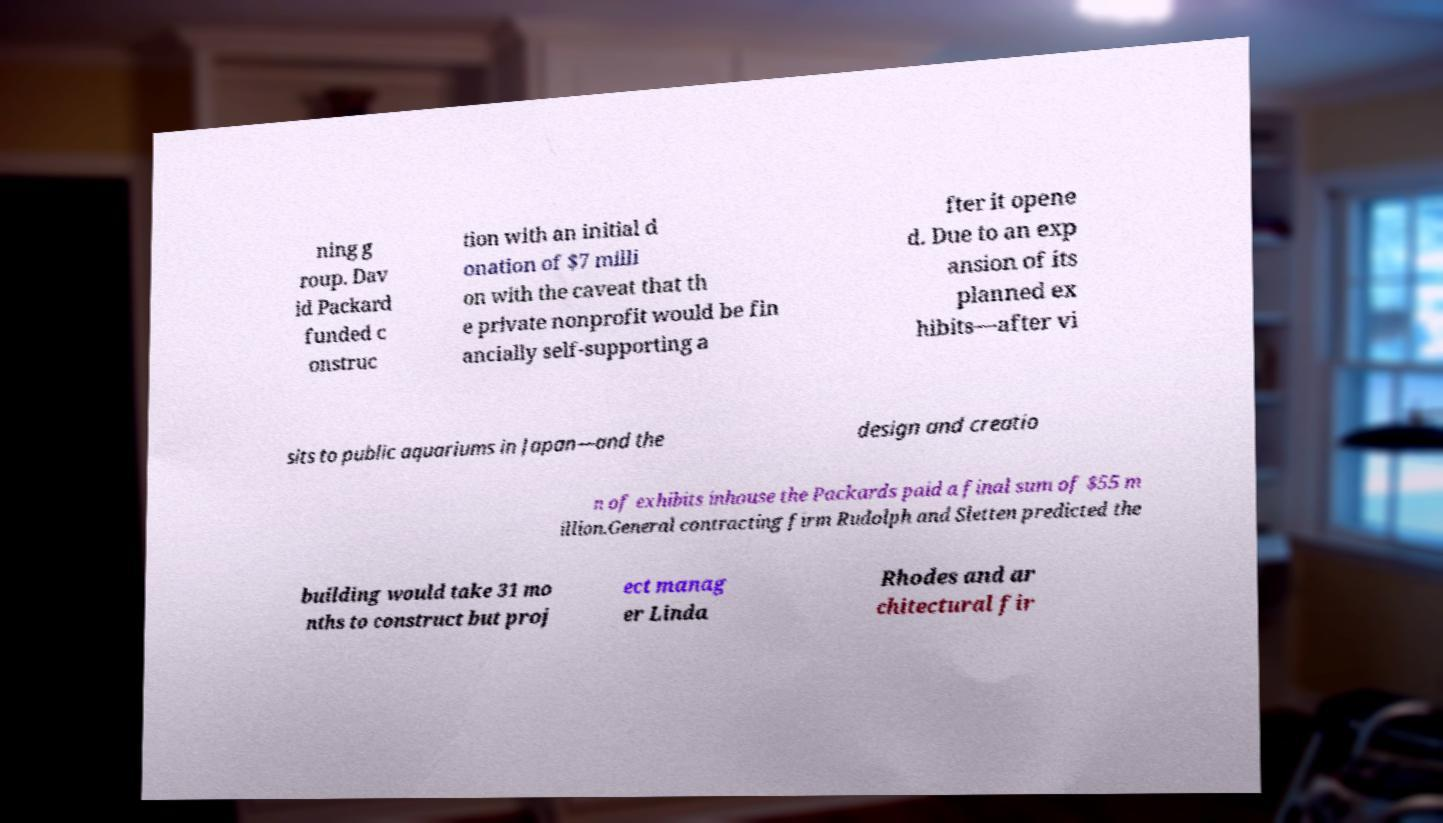I need the written content from this picture converted into text. Can you do that? ning g roup. Dav id Packard funded c onstruc tion with an initial d onation of $7 milli on with the caveat that th e private nonprofit would be fin ancially self-supporting a fter it opene d. Due to an exp ansion of its planned ex hibits—after vi sits to public aquariums in Japan—and the design and creatio n of exhibits inhouse the Packards paid a final sum of $55 m illion.General contracting firm Rudolph and Sletten predicted the building would take 31 mo nths to construct but proj ect manag er Linda Rhodes and ar chitectural fir 